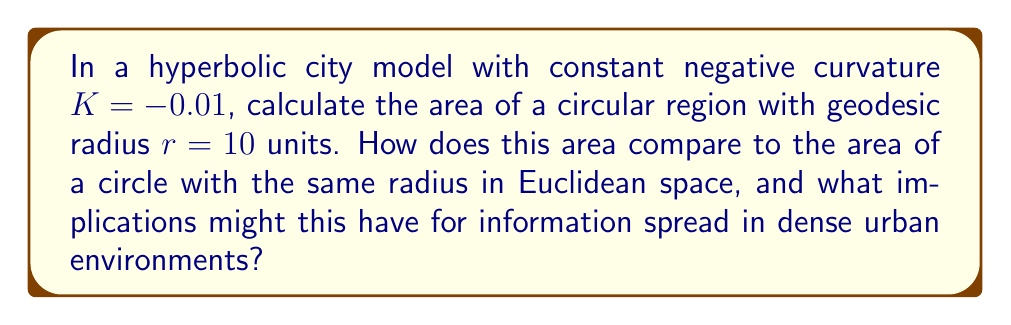Give your solution to this math problem. To solve this problem, we'll follow these steps:

1) In hyperbolic geometry, the area of a circle with geodesic radius $r$ on a surface with constant negative curvature $K$ is given by the formula:

   $$A = -\frac{4\pi}{K}(\cosh(\sqrt{-K}r) - 1)$$

2) We're given $K = -0.01$ and $r = 10$. Let's substitute these values:

   $$A = -\frac{4\pi}{-0.01}(\cosh(\sqrt{0.01}10) - 1)$$

3) Simplify the square root:
   
   $$A = 400\pi(\cosh(0.1) - 1)$$

4) Calculate $\cosh(0.1)$ (approximately 1.005004):

   $$A \approx 400\pi(1.005004 - 1) = 400\pi(0.005004) \approx 6.28502$$

5) For comparison, the area of a Euclidean circle with radius 10 is:

   $$A_E = \pi r^2 = \pi(10)^2 = 100\pi \approx 314.159$$

6) The hyperbolic area is much smaller than the Euclidean area. This implies that in a hyperbolic model of an urban environment, information would spread more slowly than in a flat model, as the actual area covered is smaller for the same radius.

7) This could model how privacy concerns in dense urban areas might limit the spread of information, aligning with the persona's hesitation about big city life.
Answer: $A \approx 6.28502$ square units, significantly smaller than the Euclidean equivalent of $314.159$ square units. 